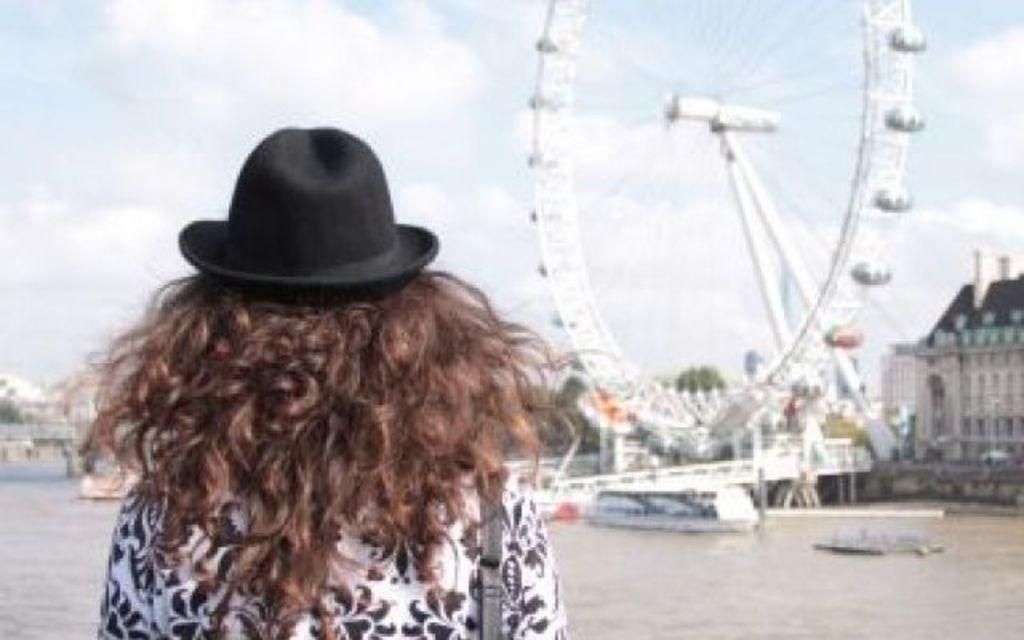Please provide a concise description of this image. In this image we can see a lady wearing a hat. On the right we can see a giant wheel and there are buildings. We can see trees. At the top there is sky. At the bottom there is water and we can see boats on the water. 